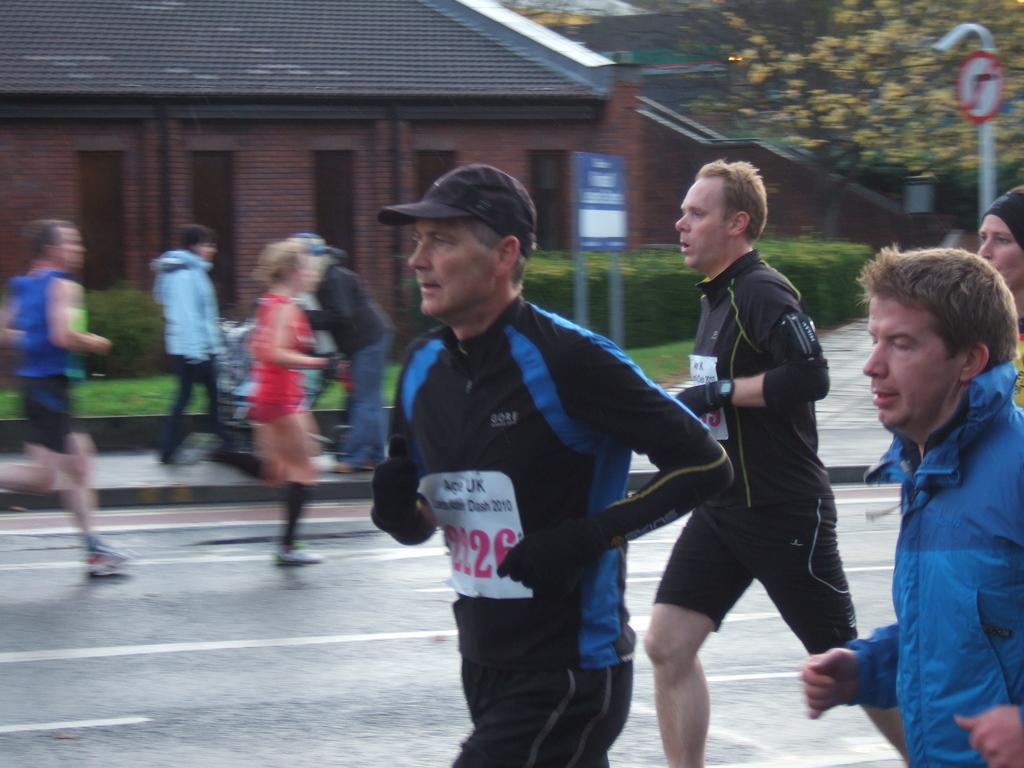What are the people in the image doing? There is a group of people running on the road. Are there any people who are not running in the image? Yes, some people are standing on a footpath. What can be seen besides the people in the image? Sign boards, a house, and trees are present in the image. What type of growth can be seen on the trees in the image? There is no indication of growth on the trees in the image; we can only see the trees themselves. 